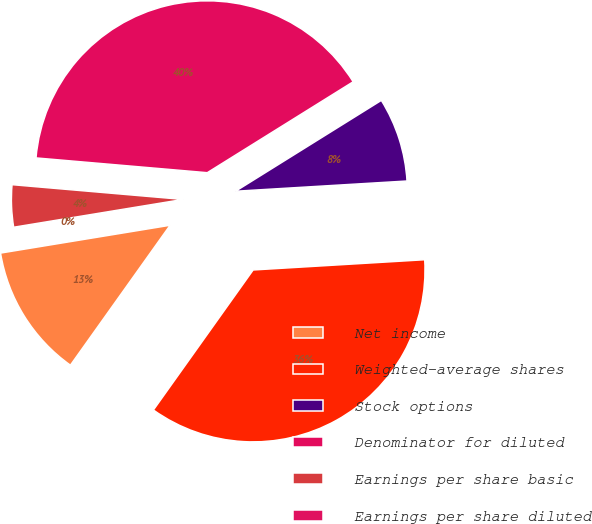Convert chart to OTSL. <chart><loc_0><loc_0><loc_500><loc_500><pie_chart><fcel>Net income<fcel>Weighted-average shares<fcel>Stock options<fcel>Denominator for diluted<fcel>Earnings per share basic<fcel>Earnings per share diluted<nl><fcel>12.56%<fcel>35.8%<fcel>7.92%<fcel>39.76%<fcel>3.96%<fcel>0.0%<nl></chart> 